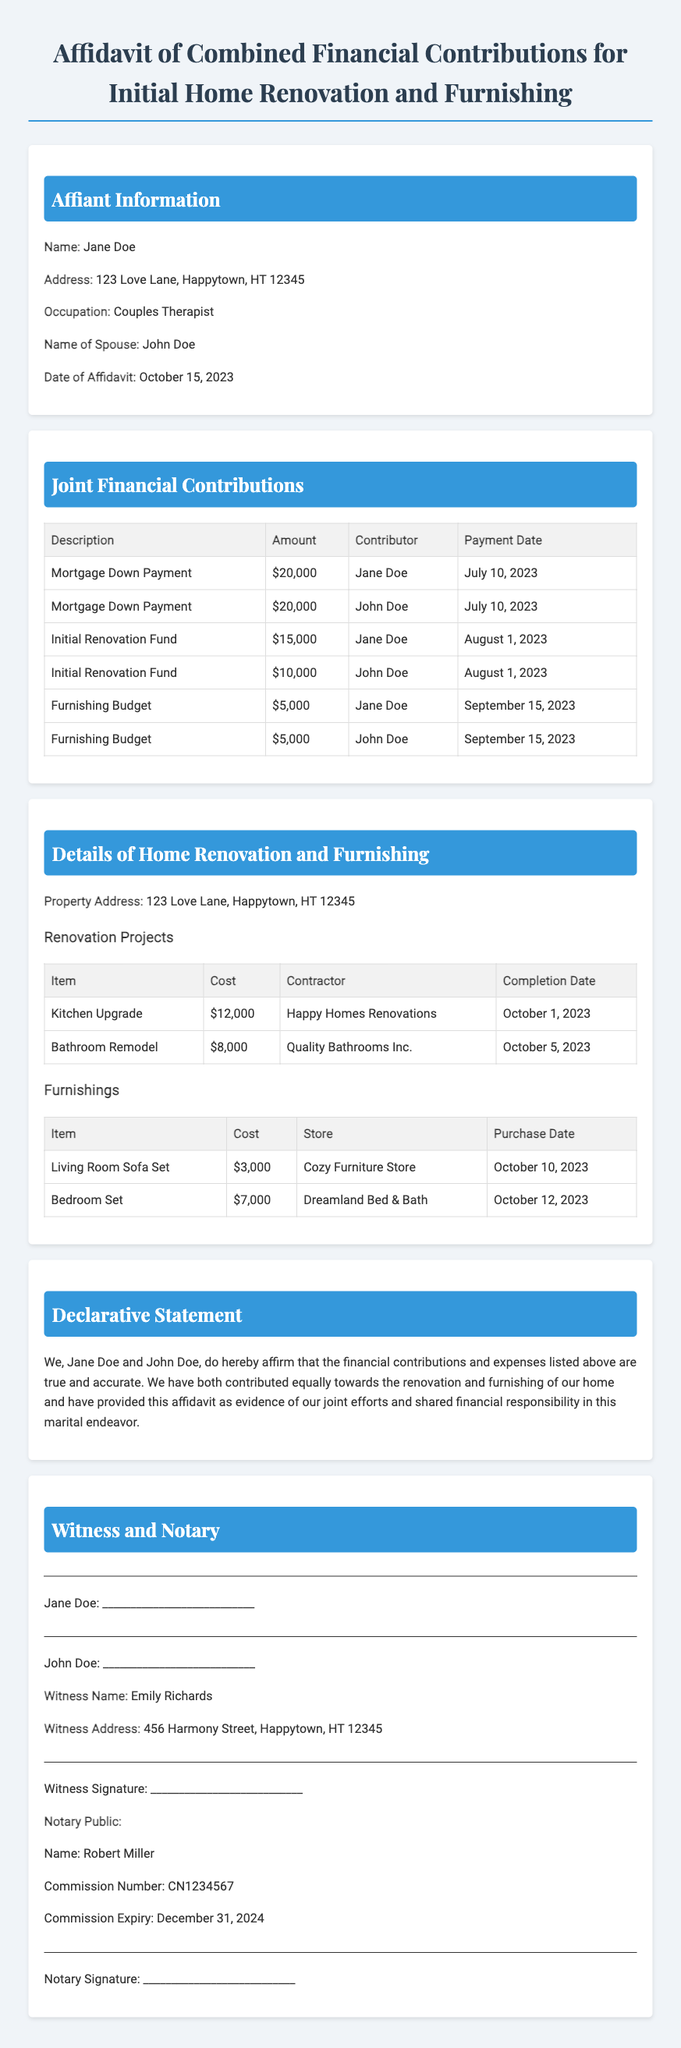What is the name of the affiant? The name of the affiant is mentioned at the beginning of the document.
Answer: Jane Doe What is the address of the property? The property address is provided in the details section of the document.
Answer: 123 Love Lane, Happytown, HT 12345 How much did John Doe contribute to the Mortgage Down Payment? The contribution amount is specified in the Joint Financial Contributions table in the document.
Answer: $20,000 What is the total cost of the Kitchen Upgrade? The cost is listed in the Renovation Projects section of the document.
Answer: $12,000 Who is the witness for this affidavit? The document provides the name of the witness near the end section.
Answer: Emily Richards What is the completion date for the Bathroom Remodel? The completion date is stated in the Renovation Projects table of the document.
Answer: October 5, 2023 What is the combined total contribution for the Furnishing Budget from both Jane and John Doe? The total contribution is derived from the entries in the Joint Financial Contributions table regarding Furnishing Budget.
Answer: $10,000 Which contractor was used for the Kitchen Upgrade? This information can be found in the Renovation Projects section of the document.
Answer: Happy Homes Renovations What is the signature line indicating? The signature line indicates where the affiant and spouse must sign to affirm the affidavit.
Answer: Affiant's signature section 